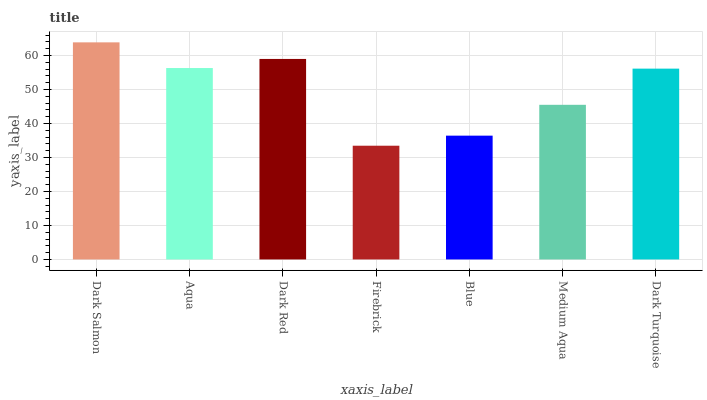Is Firebrick the minimum?
Answer yes or no. Yes. Is Dark Salmon the maximum?
Answer yes or no. Yes. Is Aqua the minimum?
Answer yes or no. No. Is Aqua the maximum?
Answer yes or no. No. Is Dark Salmon greater than Aqua?
Answer yes or no. Yes. Is Aqua less than Dark Salmon?
Answer yes or no. Yes. Is Aqua greater than Dark Salmon?
Answer yes or no. No. Is Dark Salmon less than Aqua?
Answer yes or no. No. Is Dark Turquoise the high median?
Answer yes or no. Yes. Is Dark Turquoise the low median?
Answer yes or no. Yes. Is Medium Aqua the high median?
Answer yes or no. No. Is Aqua the low median?
Answer yes or no. No. 